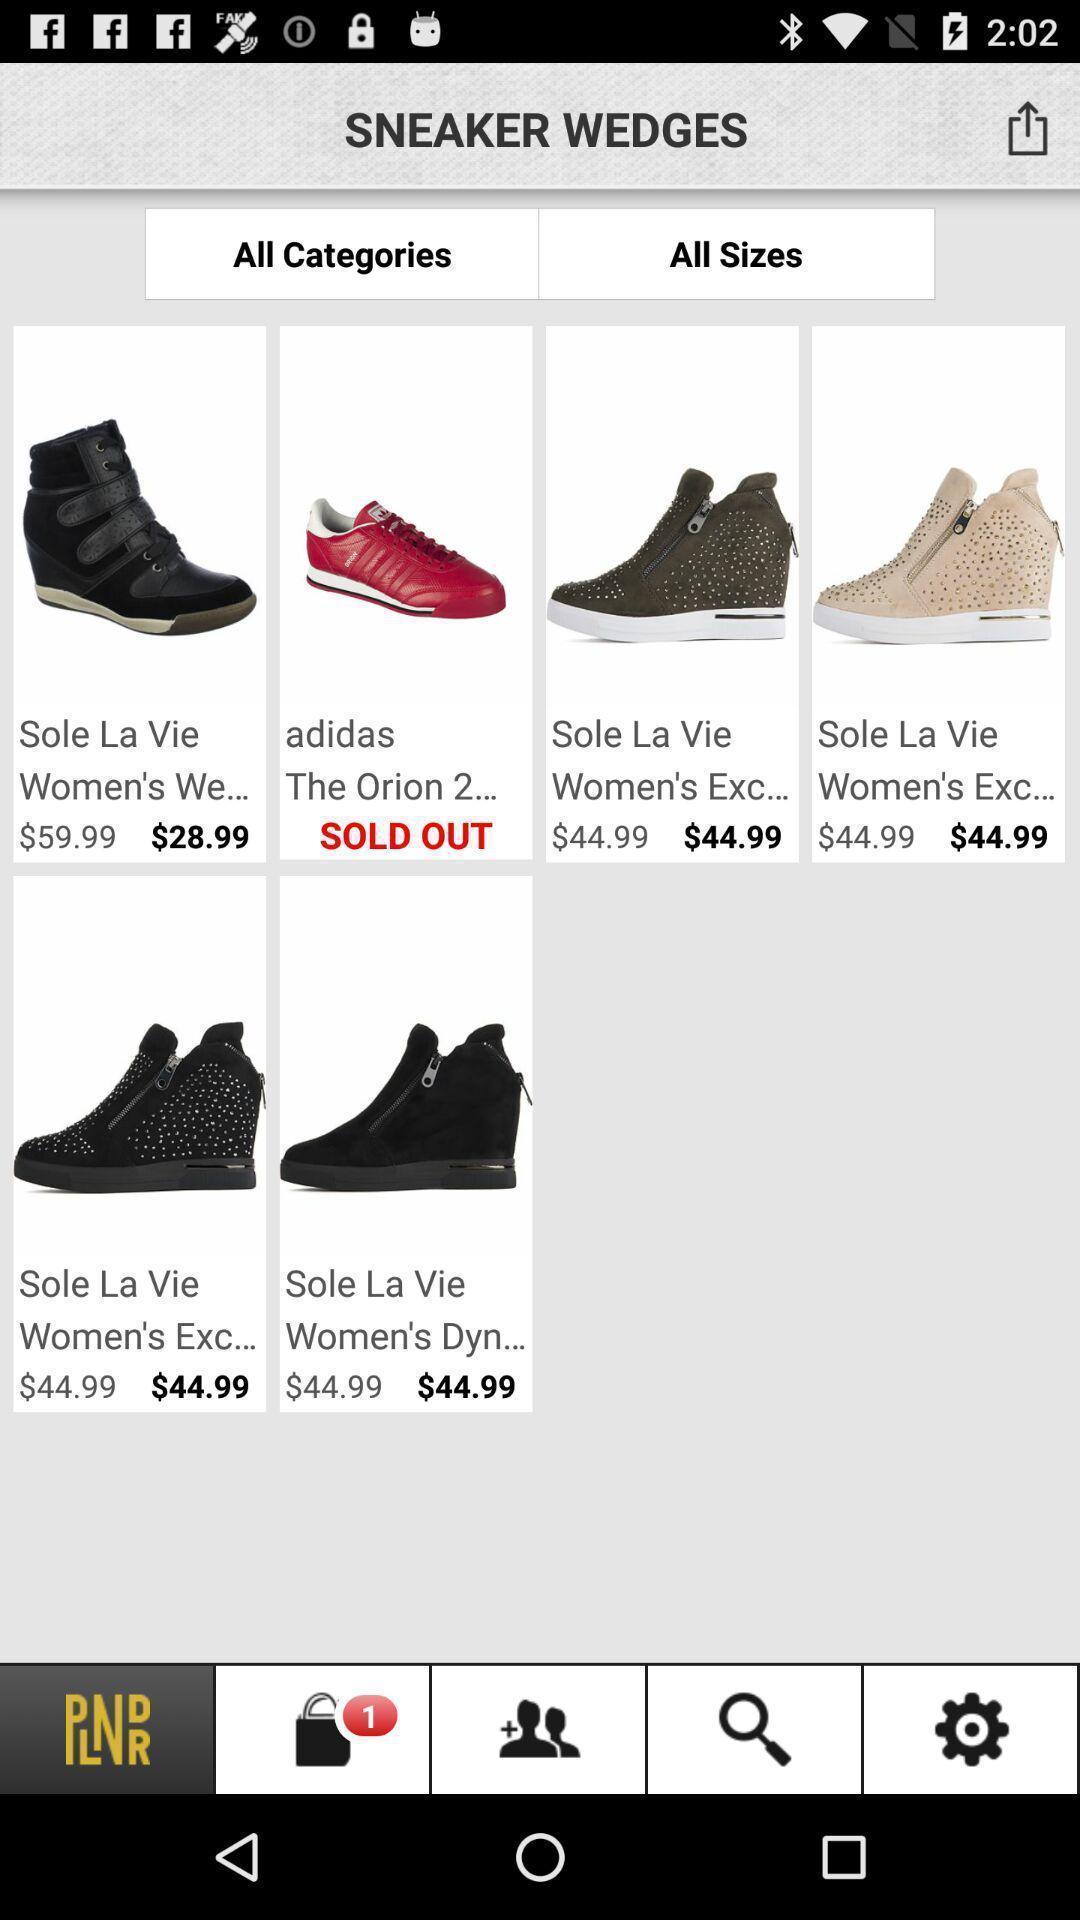Summarize the information in this screenshot. Page showing products in a shopping based app. 